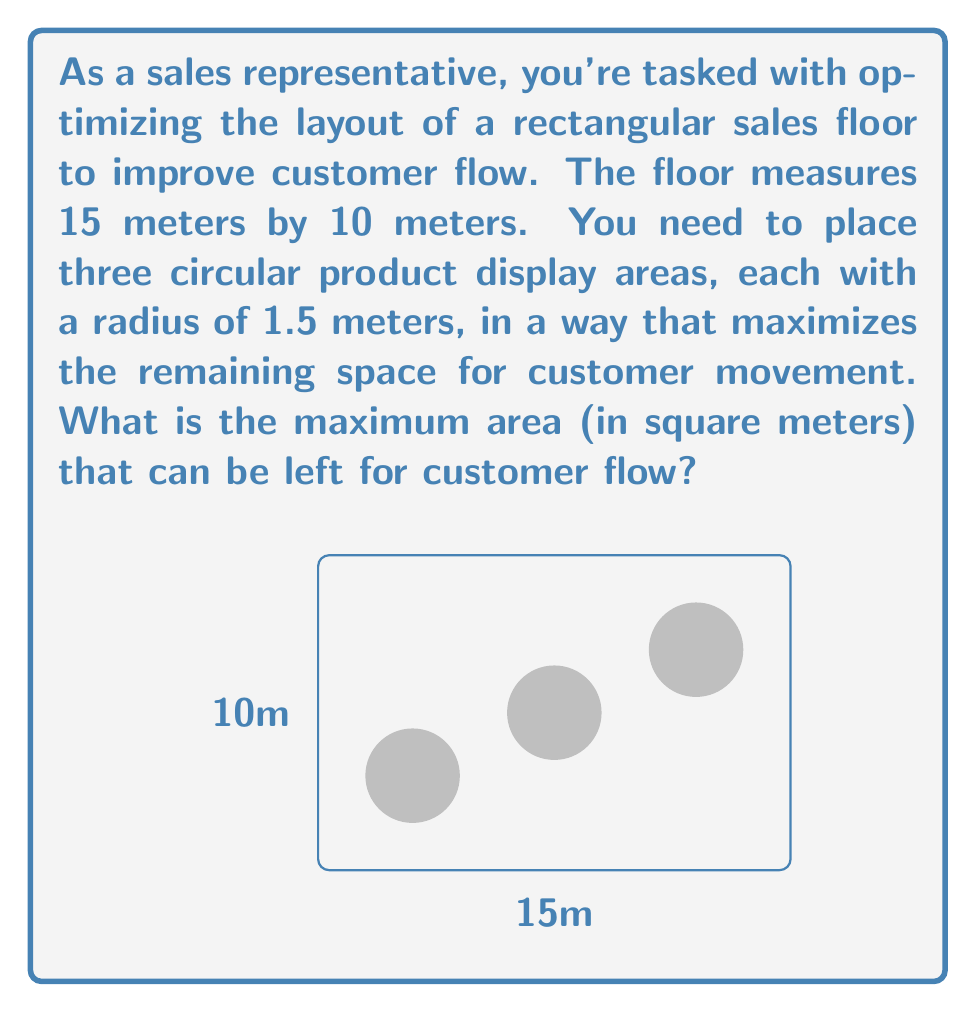Can you answer this question? Let's approach this step-by-step:

1) First, calculate the total area of the sales floor:
   $A_{total} = 15m \times 10m = 150m^2$

2) Now, calculate the area of each circular display:
   $A_{circle} = \pi r^2 = \pi (1.5m)^2 = 2.25\pi m^2$

3) There are three such circles, so the total area occupied by displays is:
   $A_{displays} = 3 \times 2.25\pi m^2 = 6.75\pi m^2$

4) To maximize the remaining space, we need to subtract the area of the displays from the total area:
   $A_{remaining} = A_{total} - A_{displays}$
   $A_{remaining} = 150m^2 - 6.75\pi m^2$

5) Simplify:
   $A_{remaining} = 150 - 6.75\pi m^2$
   $A_{remaining} \approx 128.80 m^2$

Therefore, the maximum area left for customer flow is approximately 128.80 square meters.
Answer: $150 - 6.75\pi m^2$ (≈ 128.80 $m^2$) 